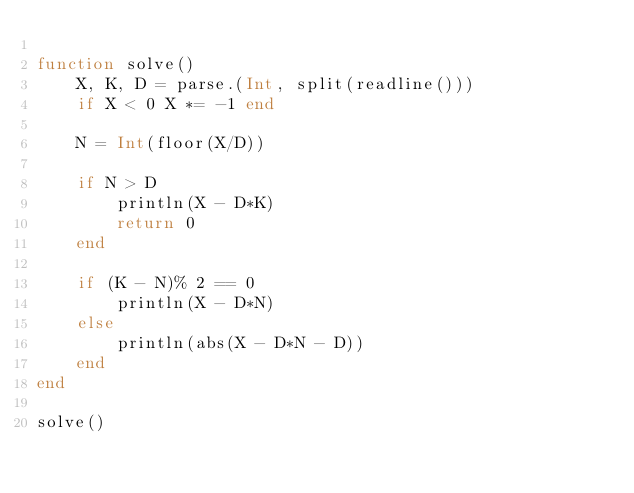<code> <loc_0><loc_0><loc_500><loc_500><_Julia_>
function solve()
    X, K, D = parse.(Int, split(readline()))
    if X < 0 X *= -1 end

    N = Int(floor(X/D))

    if N > D
        println(X - D*K)
        return 0
    end

    if (K - N)% 2 == 0
        println(X - D*N)
    else
        println(abs(X - D*N - D))
    end
end

solve()
</code> 